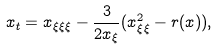<formula> <loc_0><loc_0><loc_500><loc_500>x _ { t } = x _ { \xi \xi \xi } - \frac { 3 } { 2 x _ { \xi } } ( x _ { \xi \xi } ^ { 2 } - r ( x ) ) ,</formula> 